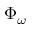Convert formula to latex. <formula><loc_0><loc_0><loc_500><loc_500>\Phi _ { \omega }</formula> 